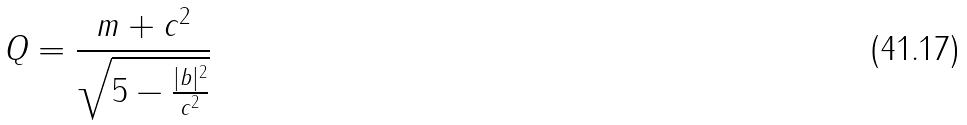<formula> <loc_0><loc_0><loc_500><loc_500>Q = \frac { m + c ^ { 2 } } { \sqrt { 5 - \frac { | b | ^ { 2 } } { c ^ { 2 } } } }</formula> 